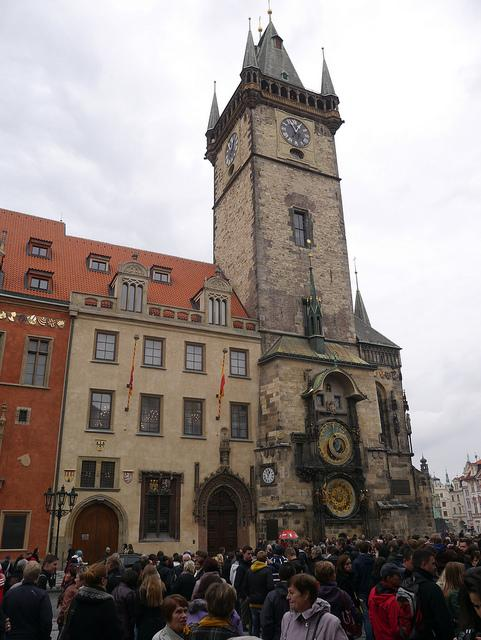What is the black circular object near the top of the tower used for? Please explain your reasoning. telling time. The circular object is a clock. 